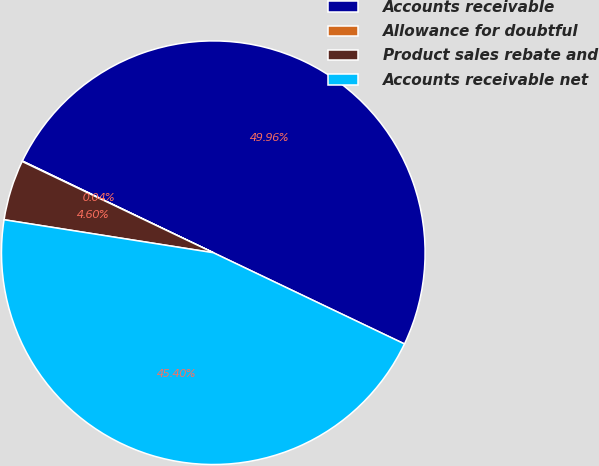Convert chart. <chart><loc_0><loc_0><loc_500><loc_500><pie_chart><fcel>Accounts receivable<fcel>Allowance for doubtful<fcel>Product sales rebate and<fcel>Accounts receivable net<nl><fcel>49.96%<fcel>0.04%<fcel>4.6%<fcel>45.4%<nl></chart> 